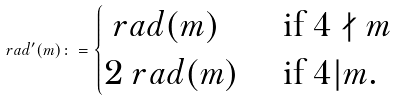<formula> <loc_0><loc_0><loc_500><loc_500>\ r a d ^ { \prime } ( m ) \colon = \begin{cases} \ r a d ( m ) & \text { if } 4 \nmid m \\ 2 \ r a d ( m ) & \text { if } 4 | m . \end{cases}</formula> 